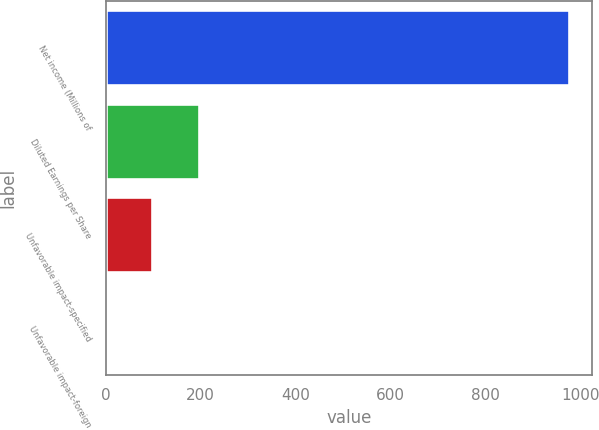Convert chart. <chart><loc_0><loc_0><loc_500><loc_500><bar_chart><fcel>Net income (Millions of<fcel>Diluted Earnings per Share<fcel>Unfavorable impact-specified<fcel>Unfavorable impact-foreign<nl><fcel>976<fcel>195.72<fcel>98.18<fcel>0.64<nl></chart> 